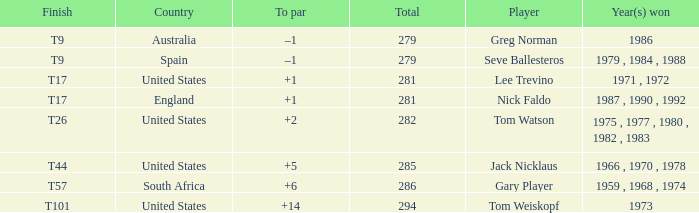Who has the highest total and a to par of +14? 294.0. 